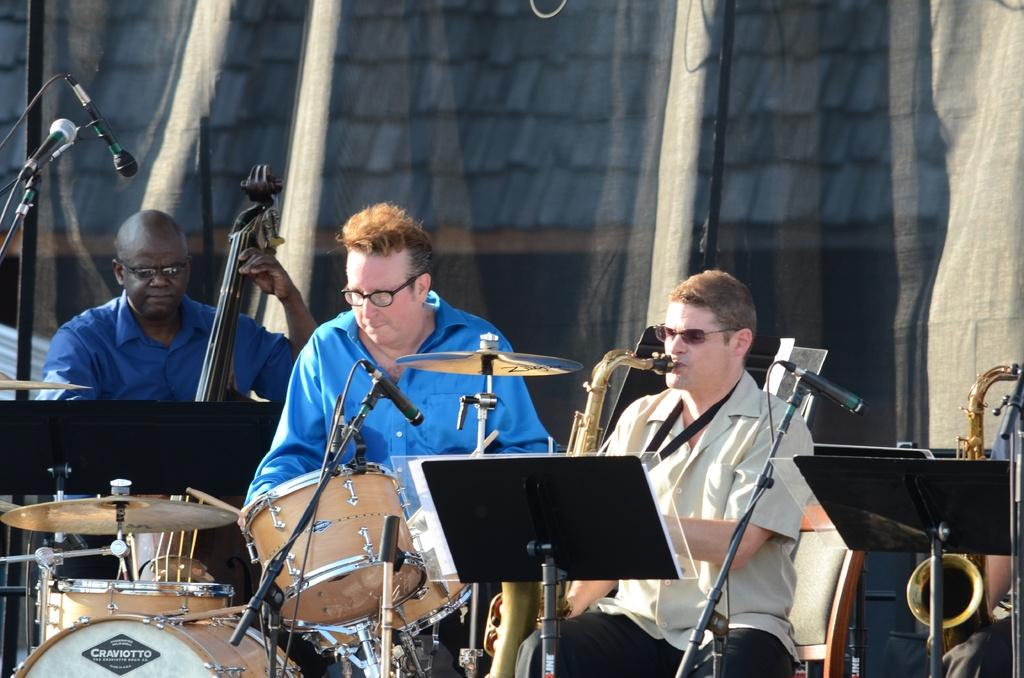What are the two musical instruments being played in the image? There is a person playing a saxophone and a person playing drums in the image. How many people are playing musical instruments in the image? There are three people playing musical instruments in the image. What type of wave can be seen crashing against the steel structure in the image? There is no wave or steel structure present in the image; it features people playing musical instruments. 